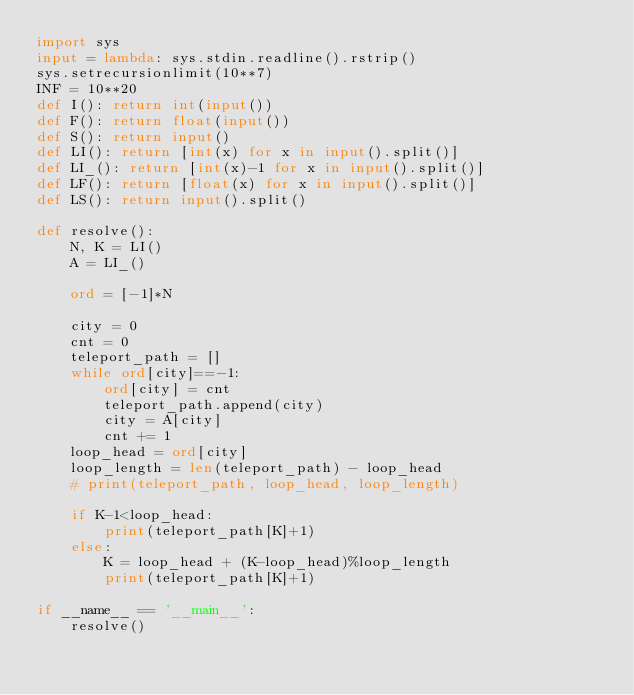<code> <loc_0><loc_0><loc_500><loc_500><_Python_>import sys
input = lambda: sys.stdin.readline().rstrip() 
sys.setrecursionlimit(10**7)
INF = 10**20
def I(): return int(input())
def F(): return float(input())
def S(): return input()
def LI(): return [int(x) for x in input().split()]
def LI_(): return [int(x)-1 for x in input().split()]
def LF(): return [float(x) for x in input().split()]
def LS(): return input().split()

def resolve():
    N, K = LI()
    A = LI_()

    ord = [-1]*N

    city = 0
    cnt = 0
    teleport_path = []
    while ord[city]==-1:
        ord[city] = cnt
        teleport_path.append(city)
        city = A[city]
        cnt += 1
    loop_head = ord[city]
    loop_length = len(teleport_path) - loop_head
    # print(teleport_path, loop_head, loop_length)

    if K-1<loop_head:
        print(teleport_path[K]+1)
    else:
        K = loop_head + (K-loop_head)%loop_length
        print(teleport_path[K]+1)

if __name__ == '__main__':
    resolve()</code> 